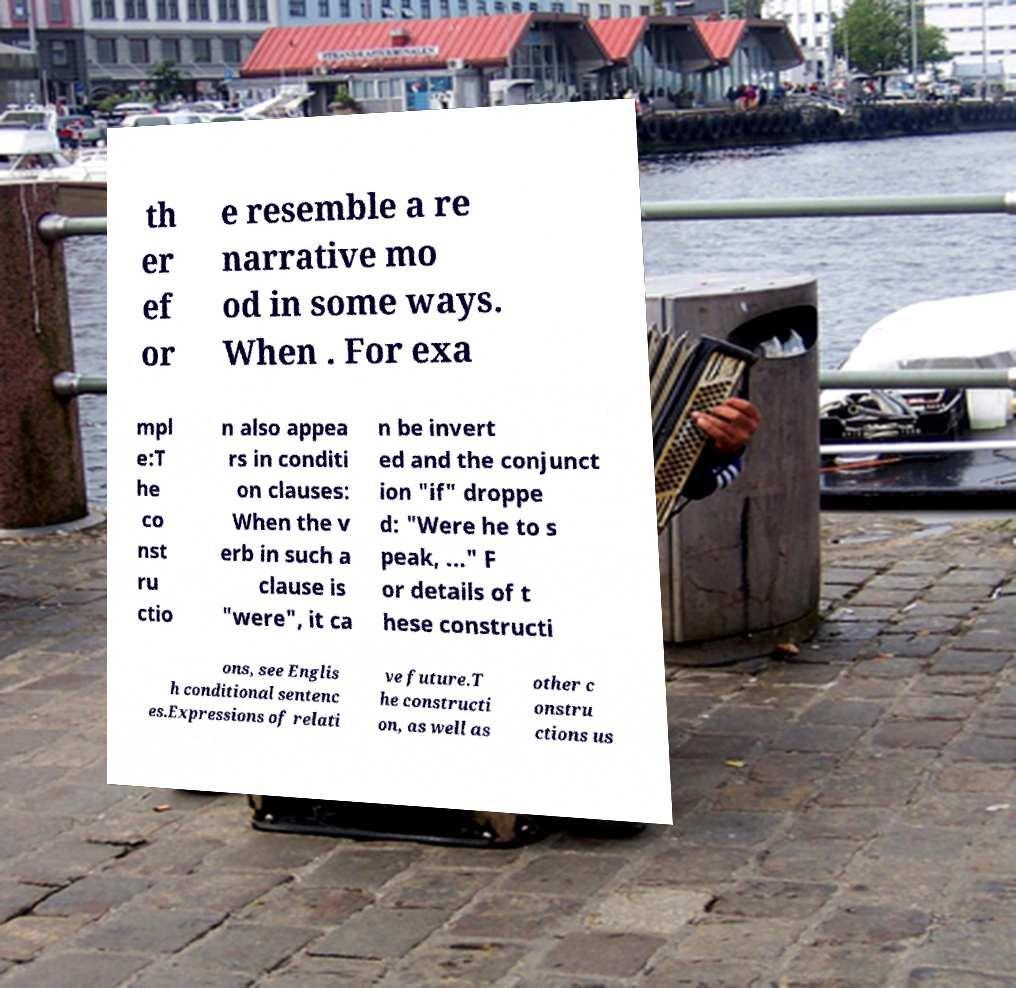Can you read and provide the text displayed in the image?This photo seems to have some interesting text. Can you extract and type it out for me? th er ef or e resemble a re narrative mo od in some ways. When . For exa mpl e:T he co nst ru ctio n also appea rs in conditi on clauses: When the v erb in such a clause is "were", it ca n be invert ed and the conjunct ion "if" droppe d: "Were he to s peak, ..." F or details of t hese constructi ons, see Englis h conditional sentenc es.Expressions of relati ve future.T he constructi on, as well as other c onstru ctions us 